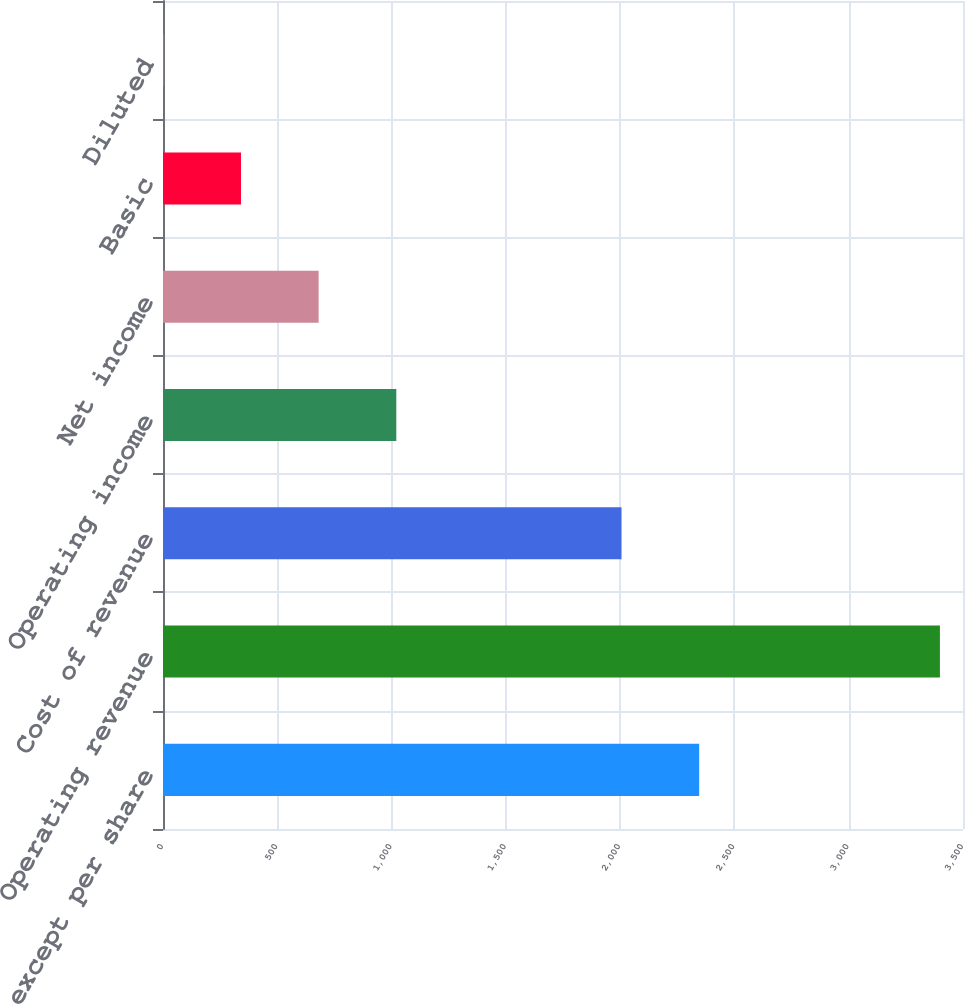Convert chart to OTSL. <chart><loc_0><loc_0><loc_500><loc_500><bar_chart><fcel>In millions except per share<fcel>Operating revenue<fcel>Cost of revenue<fcel>Operating income<fcel>Net income<fcel>Basic<fcel>Diluted<nl><fcel>2345.76<fcel>3399<fcel>2006<fcel>1020.73<fcel>680.97<fcel>341.21<fcel>1.45<nl></chart> 